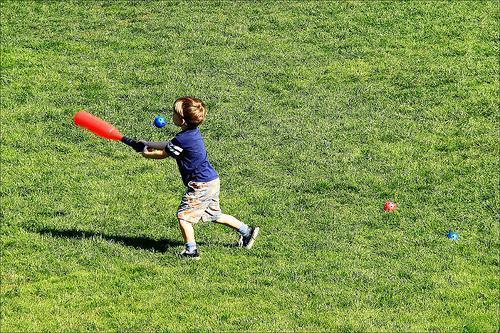How many balls are on the ground?
Give a very brief answer. 2. 